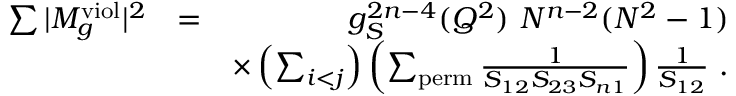Convert formula to latex. <formula><loc_0><loc_0><loc_500><loc_500>\begin{array} { r l r } { \sum | M _ { g } ^ { v i o l } | ^ { 2 } } & { = } & { g _ { S } ^ { 2 n - 4 } ( Q ^ { 2 } ) N ^ { n - 2 } ( N ^ { 2 } - 1 ) } \\ & { \times \left ( \sum _ { i < j } \right ) \left ( \sum _ { p e r m } \frac { 1 } { S _ { 1 2 } S _ { 2 3 } S _ { n 1 } } \right ) \frac { 1 } { S _ { 1 2 } } . } \end{array}</formula> 